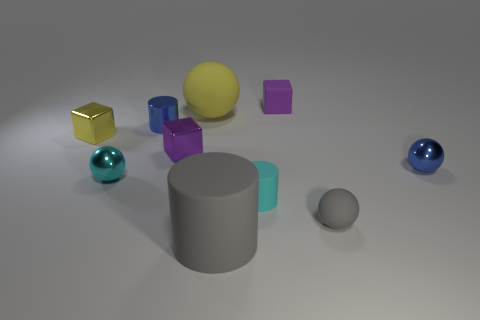Is the number of yellow shiny objects behind the big yellow matte object greater than the number of big brown matte cubes?
Your answer should be very brief. No. What number of other objects are there of the same size as the yellow shiny object?
Make the answer very short. 7. There is a tiny blue metal cylinder; what number of tiny metallic things are behind it?
Your answer should be compact. 0. Are there an equal number of big balls that are on the left side of the cyan metallic sphere and small shiny cylinders on the right side of the large yellow object?
Give a very brief answer. Yes. What size is the yellow object that is the same shape as the tiny purple rubber thing?
Give a very brief answer. Small. What is the shape of the blue thing that is on the right side of the large gray rubber cylinder?
Offer a terse response. Sphere. Is the yellow object in front of the tiny shiny cylinder made of the same material as the large thing that is behind the tiny gray thing?
Provide a short and direct response. No. The yellow matte object has what shape?
Make the answer very short. Sphere. Is the number of matte objects that are behind the cyan cylinder the same as the number of purple matte blocks?
Provide a short and direct response. No. What is the size of the metallic block that is the same color as the large sphere?
Give a very brief answer. Small. 